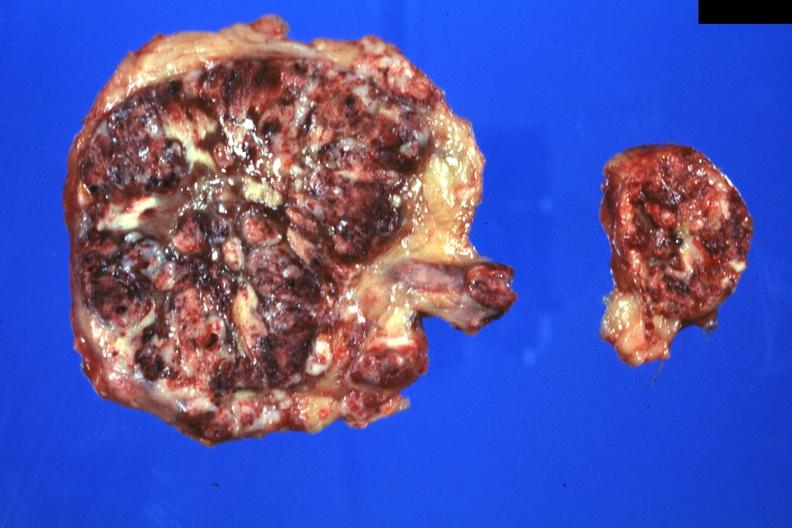what is present?
Answer the question using a single word or phrase. Metastatic carcinoma lung 